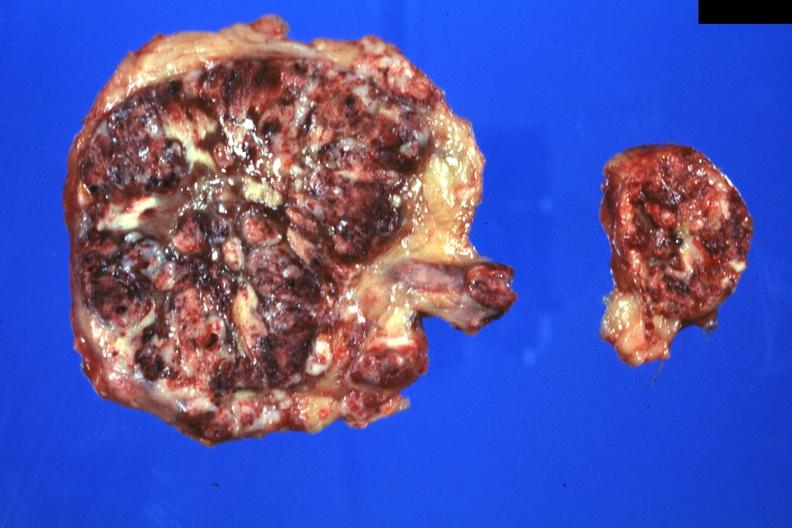what is present?
Answer the question using a single word or phrase. Metastatic carcinoma lung 